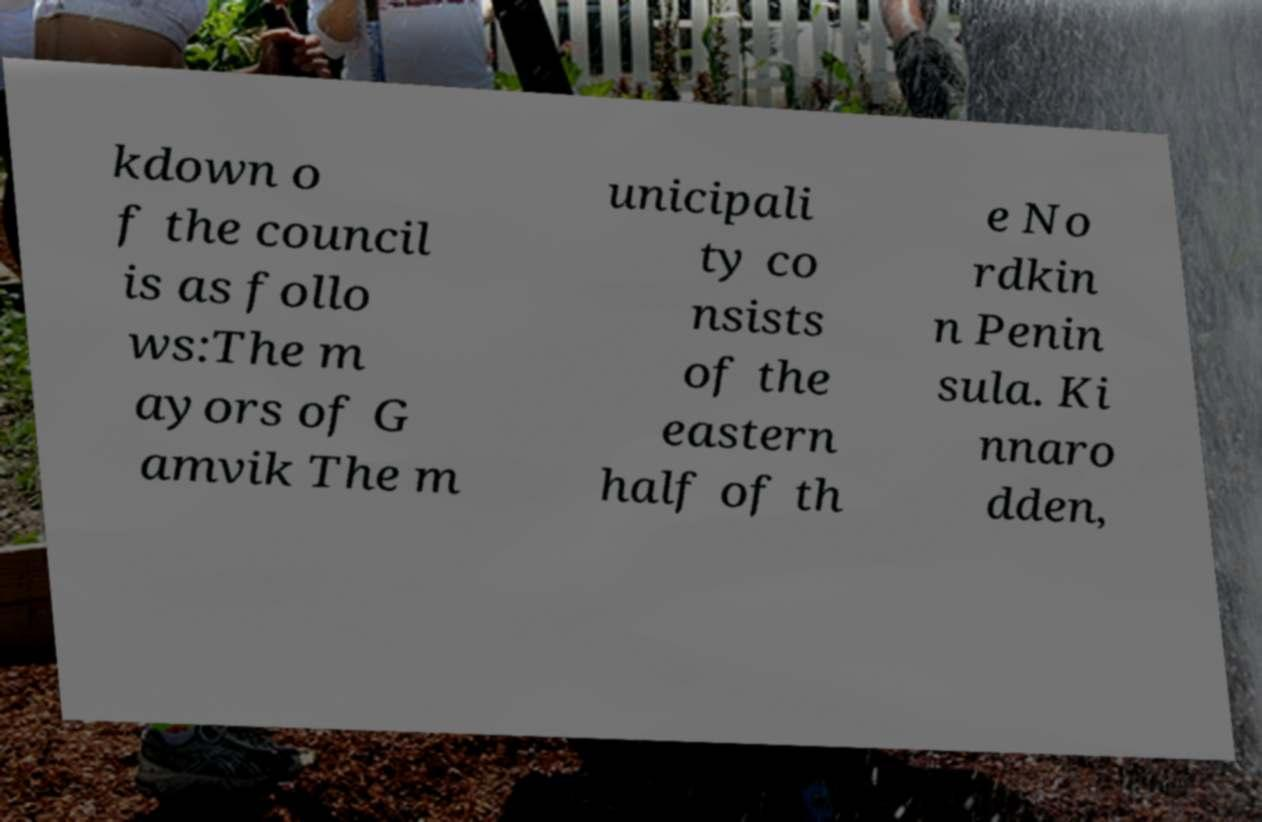Can you accurately transcribe the text from the provided image for me? kdown o f the council is as follo ws:The m ayors of G amvik The m unicipali ty co nsists of the eastern half of th e No rdkin n Penin sula. Ki nnaro dden, 